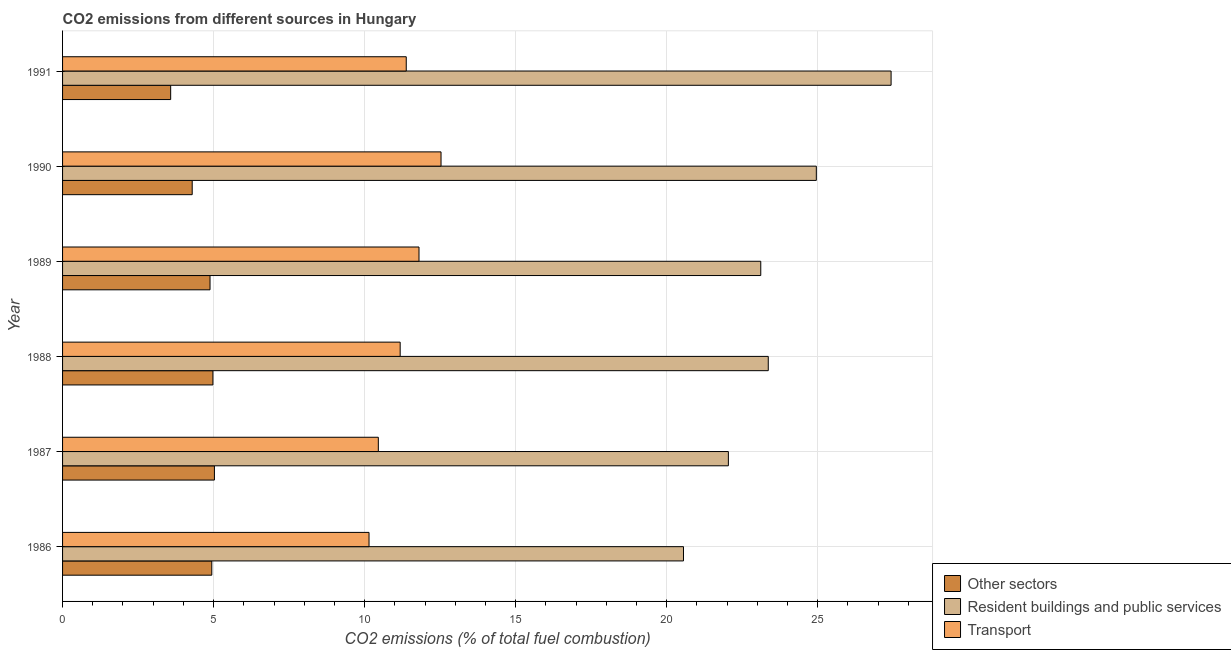How many different coloured bars are there?
Make the answer very short. 3. Are the number of bars per tick equal to the number of legend labels?
Ensure brevity in your answer.  Yes. How many bars are there on the 5th tick from the top?
Keep it short and to the point. 3. How many bars are there on the 5th tick from the bottom?
Offer a very short reply. 3. What is the label of the 2nd group of bars from the top?
Make the answer very short. 1990. What is the percentage of co2 emissions from resident buildings and public services in 1989?
Provide a succinct answer. 23.12. Across all years, what is the maximum percentage of co2 emissions from resident buildings and public services?
Give a very brief answer. 27.43. Across all years, what is the minimum percentage of co2 emissions from transport?
Your answer should be compact. 10.15. What is the total percentage of co2 emissions from transport in the graph?
Your answer should be compact. 67.49. What is the difference between the percentage of co2 emissions from transport in 1986 and that in 1987?
Your response must be concise. -0.31. What is the difference between the percentage of co2 emissions from resident buildings and public services in 1990 and the percentage of co2 emissions from transport in 1988?
Give a very brief answer. 13.78. What is the average percentage of co2 emissions from transport per year?
Your answer should be very brief. 11.25. In the year 1987, what is the difference between the percentage of co2 emissions from resident buildings and public services and percentage of co2 emissions from other sectors?
Offer a terse response. 17.02. In how many years, is the percentage of co2 emissions from transport greater than 6 %?
Offer a very short reply. 6. What is the ratio of the percentage of co2 emissions from other sectors in 1987 to that in 1988?
Your answer should be very brief. 1.01. Is the percentage of co2 emissions from other sectors in 1989 less than that in 1991?
Ensure brevity in your answer.  No. Is the difference between the percentage of co2 emissions from resident buildings and public services in 1987 and 1989 greater than the difference between the percentage of co2 emissions from transport in 1987 and 1989?
Ensure brevity in your answer.  Yes. What is the difference between the highest and the second highest percentage of co2 emissions from resident buildings and public services?
Ensure brevity in your answer.  2.48. What is the difference between the highest and the lowest percentage of co2 emissions from transport?
Keep it short and to the point. 2.38. In how many years, is the percentage of co2 emissions from resident buildings and public services greater than the average percentage of co2 emissions from resident buildings and public services taken over all years?
Keep it short and to the point. 2. What does the 2nd bar from the top in 1989 represents?
Offer a terse response. Resident buildings and public services. What does the 1st bar from the bottom in 1987 represents?
Make the answer very short. Other sectors. How many bars are there?
Make the answer very short. 18. How many years are there in the graph?
Give a very brief answer. 6. What is the difference between two consecutive major ticks on the X-axis?
Your response must be concise. 5. Are the values on the major ticks of X-axis written in scientific E-notation?
Keep it short and to the point. No. How many legend labels are there?
Your answer should be very brief. 3. What is the title of the graph?
Offer a very short reply. CO2 emissions from different sources in Hungary. Does "Natural gas sources" appear as one of the legend labels in the graph?
Give a very brief answer. No. What is the label or title of the X-axis?
Provide a short and direct response. CO2 emissions (% of total fuel combustion). What is the CO2 emissions (% of total fuel combustion) in Other sectors in 1986?
Make the answer very short. 4.94. What is the CO2 emissions (% of total fuel combustion) in Resident buildings and public services in 1986?
Your answer should be compact. 20.56. What is the CO2 emissions (% of total fuel combustion) of Transport in 1986?
Offer a terse response. 10.15. What is the CO2 emissions (% of total fuel combustion) of Other sectors in 1987?
Make the answer very short. 5.03. What is the CO2 emissions (% of total fuel combustion) in Resident buildings and public services in 1987?
Offer a very short reply. 22.04. What is the CO2 emissions (% of total fuel combustion) in Transport in 1987?
Give a very brief answer. 10.45. What is the CO2 emissions (% of total fuel combustion) in Other sectors in 1988?
Ensure brevity in your answer.  4.98. What is the CO2 emissions (% of total fuel combustion) of Resident buildings and public services in 1988?
Your answer should be very brief. 23.36. What is the CO2 emissions (% of total fuel combustion) in Transport in 1988?
Ensure brevity in your answer.  11.18. What is the CO2 emissions (% of total fuel combustion) of Other sectors in 1989?
Provide a short and direct response. 4.88. What is the CO2 emissions (% of total fuel combustion) in Resident buildings and public services in 1989?
Your response must be concise. 23.12. What is the CO2 emissions (% of total fuel combustion) in Transport in 1989?
Offer a terse response. 11.8. What is the CO2 emissions (% of total fuel combustion) in Other sectors in 1990?
Provide a short and direct response. 4.29. What is the CO2 emissions (% of total fuel combustion) of Resident buildings and public services in 1990?
Give a very brief answer. 24.95. What is the CO2 emissions (% of total fuel combustion) of Transport in 1990?
Keep it short and to the point. 12.53. What is the CO2 emissions (% of total fuel combustion) of Other sectors in 1991?
Offer a very short reply. 3.58. What is the CO2 emissions (% of total fuel combustion) in Resident buildings and public services in 1991?
Your answer should be compact. 27.43. What is the CO2 emissions (% of total fuel combustion) of Transport in 1991?
Offer a very short reply. 11.38. Across all years, what is the maximum CO2 emissions (% of total fuel combustion) of Other sectors?
Your answer should be compact. 5.03. Across all years, what is the maximum CO2 emissions (% of total fuel combustion) of Resident buildings and public services?
Provide a succinct answer. 27.43. Across all years, what is the maximum CO2 emissions (% of total fuel combustion) in Transport?
Make the answer very short. 12.53. Across all years, what is the minimum CO2 emissions (% of total fuel combustion) of Other sectors?
Keep it short and to the point. 3.58. Across all years, what is the minimum CO2 emissions (% of total fuel combustion) of Resident buildings and public services?
Provide a short and direct response. 20.56. Across all years, what is the minimum CO2 emissions (% of total fuel combustion) in Transport?
Offer a very short reply. 10.15. What is the total CO2 emissions (% of total fuel combustion) in Other sectors in the graph?
Your response must be concise. 27.7. What is the total CO2 emissions (% of total fuel combustion) of Resident buildings and public services in the graph?
Give a very brief answer. 141.46. What is the total CO2 emissions (% of total fuel combustion) of Transport in the graph?
Keep it short and to the point. 67.49. What is the difference between the CO2 emissions (% of total fuel combustion) of Other sectors in 1986 and that in 1987?
Make the answer very short. -0.09. What is the difference between the CO2 emissions (% of total fuel combustion) of Resident buildings and public services in 1986 and that in 1987?
Your response must be concise. -1.49. What is the difference between the CO2 emissions (% of total fuel combustion) in Transport in 1986 and that in 1987?
Keep it short and to the point. -0.31. What is the difference between the CO2 emissions (% of total fuel combustion) in Other sectors in 1986 and that in 1988?
Your response must be concise. -0.04. What is the difference between the CO2 emissions (% of total fuel combustion) of Resident buildings and public services in 1986 and that in 1988?
Give a very brief answer. -2.81. What is the difference between the CO2 emissions (% of total fuel combustion) of Transport in 1986 and that in 1988?
Ensure brevity in your answer.  -1.03. What is the difference between the CO2 emissions (% of total fuel combustion) of Other sectors in 1986 and that in 1989?
Offer a very short reply. 0.06. What is the difference between the CO2 emissions (% of total fuel combustion) in Resident buildings and public services in 1986 and that in 1989?
Your answer should be compact. -2.56. What is the difference between the CO2 emissions (% of total fuel combustion) in Transport in 1986 and that in 1989?
Make the answer very short. -1.65. What is the difference between the CO2 emissions (% of total fuel combustion) of Other sectors in 1986 and that in 1990?
Keep it short and to the point. 0.65. What is the difference between the CO2 emissions (% of total fuel combustion) of Resident buildings and public services in 1986 and that in 1990?
Offer a terse response. -4.4. What is the difference between the CO2 emissions (% of total fuel combustion) in Transport in 1986 and that in 1990?
Your answer should be very brief. -2.38. What is the difference between the CO2 emissions (% of total fuel combustion) of Other sectors in 1986 and that in 1991?
Make the answer very short. 1.36. What is the difference between the CO2 emissions (% of total fuel combustion) of Resident buildings and public services in 1986 and that in 1991?
Give a very brief answer. -6.87. What is the difference between the CO2 emissions (% of total fuel combustion) in Transport in 1986 and that in 1991?
Your response must be concise. -1.23. What is the difference between the CO2 emissions (% of total fuel combustion) in Other sectors in 1987 and that in 1988?
Offer a terse response. 0.05. What is the difference between the CO2 emissions (% of total fuel combustion) of Resident buildings and public services in 1987 and that in 1988?
Keep it short and to the point. -1.32. What is the difference between the CO2 emissions (% of total fuel combustion) in Transport in 1987 and that in 1988?
Your answer should be compact. -0.72. What is the difference between the CO2 emissions (% of total fuel combustion) in Other sectors in 1987 and that in 1989?
Give a very brief answer. 0.15. What is the difference between the CO2 emissions (% of total fuel combustion) of Resident buildings and public services in 1987 and that in 1989?
Provide a succinct answer. -1.07. What is the difference between the CO2 emissions (% of total fuel combustion) in Transport in 1987 and that in 1989?
Make the answer very short. -1.35. What is the difference between the CO2 emissions (% of total fuel combustion) of Other sectors in 1987 and that in 1990?
Your answer should be compact. 0.74. What is the difference between the CO2 emissions (% of total fuel combustion) in Resident buildings and public services in 1987 and that in 1990?
Your response must be concise. -2.91. What is the difference between the CO2 emissions (% of total fuel combustion) in Transport in 1987 and that in 1990?
Offer a very short reply. -2.08. What is the difference between the CO2 emissions (% of total fuel combustion) in Other sectors in 1987 and that in 1991?
Give a very brief answer. 1.45. What is the difference between the CO2 emissions (% of total fuel combustion) of Resident buildings and public services in 1987 and that in 1991?
Your answer should be compact. -5.39. What is the difference between the CO2 emissions (% of total fuel combustion) of Transport in 1987 and that in 1991?
Your answer should be very brief. -0.92. What is the difference between the CO2 emissions (% of total fuel combustion) of Other sectors in 1988 and that in 1989?
Provide a succinct answer. 0.1. What is the difference between the CO2 emissions (% of total fuel combustion) of Resident buildings and public services in 1988 and that in 1989?
Offer a very short reply. 0.25. What is the difference between the CO2 emissions (% of total fuel combustion) of Transport in 1988 and that in 1989?
Make the answer very short. -0.62. What is the difference between the CO2 emissions (% of total fuel combustion) of Other sectors in 1988 and that in 1990?
Offer a very short reply. 0.69. What is the difference between the CO2 emissions (% of total fuel combustion) in Resident buildings and public services in 1988 and that in 1990?
Provide a succinct answer. -1.59. What is the difference between the CO2 emissions (% of total fuel combustion) in Transport in 1988 and that in 1990?
Ensure brevity in your answer.  -1.35. What is the difference between the CO2 emissions (% of total fuel combustion) in Other sectors in 1988 and that in 1991?
Ensure brevity in your answer.  1.4. What is the difference between the CO2 emissions (% of total fuel combustion) of Resident buildings and public services in 1988 and that in 1991?
Offer a very short reply. -4.07. What is the difference between the CO2 emissions (% of total fuel combustion) of Transport in 1988 and that in 1991?
Your answer should be very brief. -0.2. What is the difference between the CO2 emissions (% of total fuel combustion) in Other sectors in 1989 and that in 1990?
Ensure brevity in your answer.  0.59. What is the difference between the CO2 emissions (% of total fuel combustion) in Resident buildings and public services in 1989 and that in 1990?
Offer a terse response. -1.84. What is the difference between the CO2 emissions (% of total fuel combustion) of Transport in 1989 and that in 1990?
Your answer should be very brief. -0.73. What is the difference between the CO2 emissions (% of total fuel combustion) of Other sectors in 1989 and that in 1991?
Make the answer very short. 1.3. What is the difference between the CO2 emissions (% of total fuel combustion) in Resident buildings and public services in 1989 and that in 1991?
Your answer should be very brief. -4.32. What is the difference between the CO2 emissions (% of total fuel combustion) in Transport in 1989 and that in 1991?
Keep it short and to the point. 0.42. What is the difference between the CO2 emissions (% of total fuel combustion) in Other sectors in 1990 and that in 1991?
Your response must be concise. 0.71. What is the difference between the CO2 emissions (% of total fuel combustion) of Resident buildings and public services in 1990 and that in 1991?
Provide a succinct answer. -2.48. What is the difference between the CO2 emissions (% of total fuel combustion) in Transport in 1990 and that in 1991?
Your response must be concise. 1.15. What is the difference between the CO2 emissions (% of total fuel combustion) in Other sectors in 1986 and the CO2 emissions (% of total fuel combustion) in Resident buildings and public services in 1987?
Your answer should be very brief. -17.1. What is the difference between the CO2 emissions (% of total fuel combustion) in Other sectors in 1986 and the CO2 emissions (% of total fuel combustion) in Transport in 1987?
Offer a very short reply. -5.51. What is the difference between the CO2 emissions (% of total fuel combustion) in Resident buildings and public services in 1986 and the CO2 emissions (% of total fuel combustion) in Transport in 1987?
Provide a short and direct response. 10.1. What is the difference between the CO2 emissions (% of total fuel combustion) of Other sectors in 1986 and the CO2 emissions (% of total fuel combustion) of Resident buildings and public services in 1988?
Ensure brevity in your answer.  -18.42. What is the difference between the CO2 emissions (% of total fuel combustion) of Other sectors in 1986 and the CO2 emissions (% of total fuel combustion) of Transport in 1988?
Provide a succinct answer. -6.24. What is the difference between the CO2 emissions (% of total fuel combustion) in Resident buildings and public services in 1986 and the CO2 emissions (% of total fuel combustion) in Transport in 1988?
Offer a terse response. 9.38. What is the difference between the CO2 emissions (% of total fuel combustion) in Other sectors in 1986 and the CO2 emissions (% of total fuel combustion) in Resident buildings and public services in 1989?
Provide a succinct answer. -18.17. What is the difference between the CO2 emissions (% of total fuel combustion) of Other sectors in 1986 and the CO2 emissions (% of total fuel combustion) of Transport in 1989?
Provide a short and direct response. -6.86. What is the difference between the CO2 emissions (% of total fuel combustion) of Resident buildings and public services in 1986 and the CO2 emissions (% of total fuel combustion) of Transport in 1989?
Offer a very short reply. 8.76. What is the difference between the CO2 emissions (% of total fuel combustion) in Other sectors in 1986 and the CO2 emissions (% of total fuel combustion) in Resident buildings and public services in 1990?
Provide a short and direct response. -20.01. What is the difference between the CO2 emissions (% of total fuel combustion) of Other sectors in 1986 and the CO2 emissions (% of total fuel combustion) of Transport in 1990?
Give a very brief answer. -7.59. What is the difference between the CO2 emissions (% of total fuel combustion) of Resident buildings and public services in 1986 and the CO2 emissions (% of total fuel combustion) of Transport in 1990?
Offer a terse response. 8.03. What is the difference between the CO2 emissions (% of total fuel combustion) in Other sectors in 1986 and the CO2 emissions (% of total fuel combustion) in Resident buildings and public services in 1991?
Offer a terse response. -22.49. What is the difference between the CO2 emissions (% of total fuel combustion) of Other sectors in 1986 and the CO2 emissions (% of total fuel combustion) of Transport in 1991?
Give a very brief answer. -6.44. What is the difference between the CO2 emissions (% of total fuel combustion) in Resident buildings and public services in 1986 and the CO2 emissions (% of total fuel combustion) in Transport in 1991?
Your answer should be compact. 9.18. What is the difference between the CO2 emissions (% of total fuel combustion) in Other sectors in 1987 and the CO2 emissions (% of total fuel combustion) in Resident buildings and public services in 1988?
Ensure brevity in your answer.  -18.34. What is the difference between the CO2 emissions (% of total fuel combustion) of Other sectors in 1987 and the CO2 emissions (% of total fuel combustion) of Transport in 1988?
Your response must be concise. -6.15. What is the difference between the CO2 emissions (% of total fuel combustion) of Resident buildings and public services in 1987 and the CO2 emissions (% of total fuel combustion) of Transport in 1988?
Keep it short and to the point. 10.87. What is the difference between the CO2 emissions (% of total fuel combustion) of Other sectors in 1987 and the CO2 emissions (% of total fuel combustion) of Resident buildings and public services in 1989?
Offer a very short reply. -18.09. What is the difference between the CO2 emissions (% of total fuel combustion) of Other sectors in 1987 and the CO2 emissions (% of total fuel combustion) of Transport in 1989?
Keep it short and to the point. -6.77. What is the difference between the CO2 emissions (% of total fuel combustion) in Resident buildings and public services in 1987 and the CO2 emissions (% of total fuel combustion) in Transport in 1989?
Offer a very short reply. 10.24. What is the difference between the CO2 emissions (% of total fuel combustion) of Other sectors in 1987 and the CO2 emissions (% of total fuel combustion) of Resident buildings and public services in 1990?
Provide a short and direct response. -19.93. What is the difference between the CO2 emissions (% of total fuel combustion) of Other sectors in 1987 and the CO2 emissions (% of total fuel combustion) of Transport in 1990?
Offer a very short reply. -7.5. What is the difference between the CO2 emissions (% of total fuel combustion) in Resident buildings and public services in 1987 and the CO2 emissions (% of total fuel combustion) in Transport in 1990?
Provide a succinct answer. 9.51. What is the difference between the CO2 emissions (% of total fuel combustion) in Other sectors in 1987 and the CO2 emissions (% of total fuel combustion) in Resident buildings and public services in 1991?
Your answer should be very brief. -22.4. What is the difference between the CO2 emissions (% of total fuel combustion) of Other sectors in 1987 and the CO2 emissions (% of total fuel combustion) of Transport in 1991?
Your answer should be very brief. -6.35. What is the difference between the CO2 emissions (% of total fuel combustion) in Resident buildings and public services in 1987 and the CO2 emissions (% of total fuel combustion) in Transport in 1991?
Your response must be concise. 10.66. What is the difference between the CO2 emissions (% of total fuel combustion) in Other sectors in 1988 and the CO2 emissions (% of total fuel combustion) in Resident buildings and public services in 1989?
Ensure brevity in your answer.  -18.14. What is the difference between the CO2 emissions (% of total fuel combustion) in Other sectors in 1988 and the CO2 emissions (% of total fuel combustion) in Transport in 1989?
Your response must be concise. -6.82. What is the difference between the CO2 emissions (% of total fuel combustion) of Resident buildings and public services in 1988 and the CO2 emissions (% of total fuel combustion) of Transport in 1989?
Provide a succinct answer. 11.56. What is the difference between the CO2 emissions (% of total fuel combustion) of Other sectors in 1988 and the CO2 emissions (% of total fuel combustion) of Resident buildings and public services in 1990?
Offer a very short reply. -19.98. What is the difference between the CO2 emissions (% of total fuel combustion) in Other sectors in 1988 and the CO2 emissions (% of total fuel combustion) in Transport in 1990?
Provide a short and direct response. -7.55. What is the difference between the CO2 emissions (% of total fuel combustion) in Resident buildings and public services in 1988 and the CO2 emissions (% of total fuel combustion) in Transport in 1990?
Give a very brief answer. 10.83. What is the difference between the CO2 emissions (% of total fuel combustion) in Other sectors in 1988 and the CO2 emissions (% of total fuel combustion) in Resident buildings and public services in 1991?
Ensure brevity in your answer.  -22.45. What is the difference between the CO2 emissions (% of total fuel combustion) of Other sectors in 1988 and the CO2 emissions (% of total fuel combustion) of Transport in 1991?
Your answer should be compact. -6.4. What is the difference between the CO2 emissions (% of total fuel combustion) of Resident buildings and public services in 1988 and the CO2 emissions (% of total fuel combustion) of Transport in 1991?
Make the answer very short. 11.99. What is the difference between the CO2 emissions (% of total fuel combustion) of Other sectors in 1989 and the CO2 emissions (% of total fuel combustion) of Resident buildings and public services in 1990?
Offer a very short reply. -20.07. What is the difference between the CO2 emissions (% of total fuel combustion) of Other sectors in 1989 and the CO2 emissions (% of total fuel combustion) of Transport in 1990?
Your answer should be compact. -7.65. What is the difference between the CO2 emissions (% of total fuel combustion) in Resident buildings and public services in 1989 and the CO2 emissions (% of total fuel combustion) in Transport in 1990?
Ensure brevity in your answer.  10.59. What is the difference between the CO2 emissions (% of total fuel combustion) of Other sectors in 1989 and the CO2 emissions (% of total fuel combustion) of Resident buildings and public services in 1991?
Keep it short and to the point. -22.55. What is the difference between the CO2 emissions (% of total fuel combustion) in Other sectors in 1989 and the CO2 emissions (% of total fuel combustion) in Transport in 1991?
Give a very brief answer. -6.5. What is the difference between the CO2 emissions (% of total fuel combustion) of Resident buildings and public services in 1989 and the CO2 emissions (% of total fuel combustion) of Transport in 1991?
Make the answer very short. 11.74. What is the difference between the CO2 emissions (% of total fuel combustion) of Other sectors in 1990 and the CO2 emissions (% of total fuel combustion) of Resident buildings and public services in 1991?
Your response must be concise. -23.14. What is the difference between the CO2 emissions (% of total fuel combustion) of Other sectors in 1990 and the CO2 emissions (% of total fuel combustion) of Transport in 1991?
Your answer should be compact. -7.09. What is the difference between the CO2 emissions (% of total fuel combustion) of Resident buildings and public services in 1990 and the CO2 emissions (% of total fuel combustion) of Transport in 1991?
Ensure brevity in your answer.  13.58. What is the average CO2 emissions (% of total fuel combustion) of Other sectors per year?
Your answer should be compact. 4.62. What is the average CO2 emissions (% of total fuel combustion) in Resident buildings and public services per year?
Offer a terse response. 23.58. What is the average CO2 emissions (% of total fuel combustion) in Transport per year?
Your response must be concise. 11.25. In the year 1986, what is the difference between the CO2 emissions (% of total fuel combustion) in Other sectors and CO2 emissions (% of total fuel combustion) in Resident buildings and public services?
Offer a very short reply. -15.62. In the year 1986, what is the difference between the CO2 emissions (% of total fuel combustion) of Other sectors and CO2 emissions (% of total fuel combustion) of Transport?
Offer a terse response. -5.21. In the year 1986, what is the difference between the CO2 emissions (% of total fuel combustion) of Resident buildings and public services and CO2 emissions (% of total fuel combustion) of Transport?
Make the answer very short. 10.41. In the year 1987, what is the difference between the CO2 emissions (% of total fuel combustion) of Other sectors and CO2 emissions (% of total fuel combustion) of Resident buildings and public services?
Keep it short and to the point. -17.02. In the year 1987, what is the difference between the CO2 emissions (% of total fuel combustion) of Other sectors and CO2 emissions (% of total fuel combustion) of Transport?
Offer a terse response. -5.43. In the year 1987, what is the difference between the CO2 emissions (% of total fuel combustion) of Resident buildings and public services and CO2 emissions (% of total fuel combustion) of Transport?
Provide a short and direct response. 11.59. In the year 1988, what is the difference between the CO2 emissions (% of total fuel combustion) in Other sectors and CO2 emissions (% of total fuel combustion) in Resident buildings and public services?
Keep it short and to the point. -18.39. In the year 1988, what is the difference between the CO2 emissions (% of total fuel combustion) of Other sectors and CO2 emissions (% of total fuel combustion) of Transport?
Provide a succinct answer. -6.2. In the year 1988, what is the difference between the CO2 emissions (% of total fuel combustion) in Resident buildings and public services and CO2 emissions (% of total fuel combustion) in Transport?
Your answer should be very brief. 12.19. In the year 1989, what is the difference between the CO2 emissions (% of total fuel combustion) of Other sectors and CO2 emissions (% of total fuel combustion) of Resident buildings and public services?
Give a very brief answer. -18.23. In the year 1989, what is the difference between the CO2 emissions (% of total fuel combustion) of Other sectors and CO2 emissions (% of total fuel combustion) of Transport?
Keep it short and to the point. -6.92. In the year 1989, what is the difference between the CO2 emissions (% of total fuel combustion) in Resident buildings and public services and CO2 emissions (% of total fuel combustion) in Transport?
Offer a very short reply. 11.31. In the year 1990, what is the difference between the CO2 emissions (% of total fuel combustion) in Other sectors and CO2 emissions (% of total fuel combustion) in Resident buildings and public services?
Make the answer very short. -20.66. In the year 1990, what is the difference between the CO2 emissions (% of total fuel combustion) in Other sectors and CO2 emissions (% of total fuel combustion) in Transport?
Your response must be concise. -8.24. In the year 1990, what is the difference between the CO2 emissions (% of total fuel combustion) in Resident buildings and public services and CO2 emissions (% of total fuel combustion) in Transport?
Your response must be concise. 12.42. In the year 1991, what is the difference between the CO2 emissions (% of total fuel combustion) in Other sectors and CO2 emissions (% of total fuel combustion) in Resident buildings and public services?
Provide a short and direct response. -23.85. In the year 1991, what is the difference between the CO2 emissions (% of total fuel combustion) in Other sectors and CO2 emissions (% of total fuel combustion) in Transport?
Offer a terse response. -7.8. In the year 1991, what is the difference between the CO2 emissions (% of total fuel combustion) of Resident buildings and public services and CO2 emissions (% of total fuel combustion) of Transport?
Your answer should be compact. 16.05. What is the ratio of the CO2 emissions (% of total fuel combustion) of Other sectors in 1986 to that in 1987?
Keep it short and to the point. 0.98. What is the ratio of the CO2 emissions (% of total fuel combustion) in Resident buildings and public services in 1986 to that in 1987?
Make the answer very short. 0.93. What is the ratio of the CO2 emissions (% of total fuel combustion) of Transport in 1986 to that in 1987?
Ensure brevity in your answer.  0.97. What is the ratio of the CO2 emissions (% of total fuel combustion) in Resident buildings and public services in 1986 to that in 1988?
Give a very brief answer. 0.88. What is the ratio of the CO2 emissions (% of total fuel combustion) of Transport in 1986 to that in 1988?
Your answer should be compact. 0.91. What is the ratio of the CO2 emissions (% of total fuel combustion) of Resident buildings and public services in 1986 to that in 1989?
Offer a terse response. 0.89. What is the ratio of the CO2 emissions (% of total fuel combustion) of Transport in 1986 to that in 1989?
Keep it short and to the point. 0.86. What is the ratio of the CO2 emissions (% of total fuel combustion) of Other sectors in 1986 to that in 1990?
Offer a very short reply. 1.15. What is the ratio of the CO2 emissions (% of total fuel combustion) of Resident buildings and public services in 1986 to that in 1990?
Give a very brief answer. 0.82. What is the ratio of the CO2 emissions (% of total fuel combustion) of Transport in 1986 to that in 1990?
Your answer should be compact. 0.81. What is the ratio of the CO2 emissions (% of total fuel combustion) in Other sectors in 1986 to that in 1991?
Your answer should be compact. 1.38. What is the ratio of the CO2 emissions (% of total fuel combustion) in Resident buildings and public services in 1986 to that in 1991?
Provide a short and direct response. 0.75. What is the ratio of the CO2 emissions (% of total fuel combustion) of Transport in 1986 to that in 1991?
Provide a succinct answer. 0.89. What is the ratio of the CO2 emissions (% of total fuel combustion) of Other sectors in 1987 to that in 1988?
Provide a short and direct response. 1.01. What is the ratio of the CO2 emissions (% of total fuel combustion) of Resident buildings and public services in 1987 to that in 1988?
Ensure brevity in your answer.  0.94. What is the ratio of the CO2 emissions (% of total fuel combustion) in Transport in 1987 to that in 1988?
Offer a very short reply. 0.94. What is the ratio of the CO2 emissions (% of total fuel combustion) of Other sectors in 1987 to that in 1989?
Your answer should be very brief. 1.03. What is the ratio of the CO2 emissions (% of total fuel combustion) of Resident buildings and public services in 1987 to that in 1989?
Offer a very short reply. 0.95. What is the ratio of the CO2 emissions (% of total fuel combustion) in Transport in 1987 to that in 1989?
Offer a terse response. 0.89. What is the ratio of the CO2 emissions (% of total fuel combustion) in Other sectors in 1987 to that in 1990?
Offer a very short reply. 1.17. What is the ratio of the CO2 emissions (% of total fuel combustion) in Resident buildings and public services in 1987 to that in 1990?
Your answer should be compact. 0.88. What is the ratio of the CO2 emissions (% of total fuel combustion) in Transport in 1987 to that in 1990?
Offer a very short reply. 0.83. What is the ratio of the CO2 emissions (% of total fuel combustion) of Other sectors in 1987 to that in 1991?
Offer a very short reply. 1.4. What is the ratio of the CO2 emissions (% of total fuel combustion) in Resident buildings and public services in 1987 to that in 1991?
Give a very brief answer. 0.8. What is the ratio of the CO2 emissions (% of total fuel combustion) in Transport in 1987 to that in 1991?
Offer a very short reply. 0.92. What is the ratio of the CO2 emissions (% of total fuel combustion) in Other sectors in 1988 to that in 1989?
Your answer should be very brief. 1.02. What is the ratio of the CO2 emissions (% of total fuel combustion) of Resident buildings and public services in 1988 to that in 1989?
Keep it short and to the point. 1.01. What is the ratio of the CO2 emissions (% of total fuel combustion) in Transport in 1988 to that in 1989?
Provide a short and direct response. 0.95. What is the ratio of the CO2 emissions (% of total fuel combustion) in Other sectors in 1988 to that in 1990?
Your answer should be very brief. 1.16. What is the ratio of the CO2 emissions (% of total fuel combustion) in Resident buildings and public services in 1988 to that in 1990?
Keep it short and to the point. 0.94. What is the ratio of the CO2 emissions (% of total fuel combustion) of Transport in 1988 to that in 1990?
Make the answer very short. 0.89. What is the ratio of the CO2 emissions (% of total fuel combustion) in Other sectors in 1988 to that in 1991?
Provide a short and direct response. 1.39. What is the ratio of the CO2 emissions (% of total fuel combustion) in Resident buildings and public services in 1988 to that in 1991?
Keep it short and to the point. 0.85. What is the ratio of the CO2 emissions (% of total fuel combustion) of Transport in 1988 to that in 1991?
Your response must be concise. 0.98. What is the ratio of the CO2 emissions (% of total fuel combustion) of Other sectors in 1989 to that in 1990?
Make the answer very short. 1.14. What is the ratio of the CO2 emissions (% of total fuel combustion) of Resident buildings and public services in 1989 to that in 1990?
Ensure brevity in your answer.  0.93. What is the ratio of the CO2 emissions (% of total fuel combustion) of Transport in 1989 to that in 1990?
Offer a very short reply. 0.94. What is the ratio of the CO2 emissions (% of total fuel combustion) in Other sectors in 1989 to that in 1991?
Your response must be concise. 1.36. What is the ratio of the CO2 emissions (% of total fuel combustion) in Resident buildings and public services in 1989 to that in 1991?
Your answer should be compact. 0.84. What is the ratio of the CO2 emissions (% of total fuel combustion) of Transport in 1989 to that in 1991?
Provide a succinct answer. 1.04. What is the ratio of the CO2 emissions (% of total fuel combustion) in Other sectors in 1990 to that in 1991?
Provide a short and direct response. 1.2. What is the ratio of the CO2 emissions (% of total fuel combustion) in Resident buildings and public services in 1990 to that in 1991?
Keep it short and to the point. 0.91. What is the ratio of the CO2 emissions (% of total fuel combustion) in Transport in 1990 to that in 1991?
Your answer should be compact. 1.1. What is the difference between the highest and the second highest CO2 emissions (% of total fuel combustion) of Other sectors?
Provide a succinct answer. 0.05. What is the difference between the highest and the second highest CO2 emissions (% of total fuel combustion) in Resident buildings and public services?
Provide a succinct answer. 2.48. What is the difference between the highest and the second highest CO2 emissions (% of total fuel combustion) in Transport?
Give a very brief answer. 0.73. What is the difference between the highest and the lowest CO2 emissions (% of total fuel combustion) in Other sectors?
Keep it short and to the point. 1.45. What is the difference between the highest and the lowest CO2 emissions (% of total fuel combustion) of Resident buildings and public services?
Offer a terse response. 6.87. What is the difference between the highest and the lowest CO2 emissions (% of total fuel combustion) in Transport?
Your answer should be compact. 2.38. 